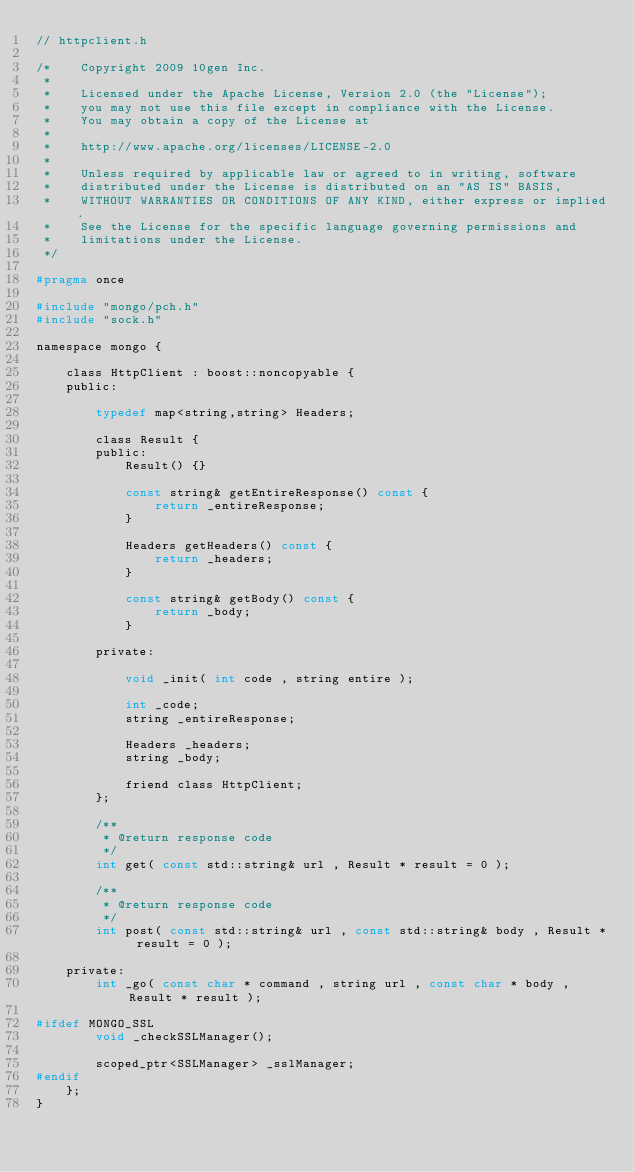Convert code to text. <code><loc_0><loc_0><loc_500><loc_500><_C_>// httpclient.h

/*    Copyright 2009 10gen Inc.
 *
 *    Licensed under the Apache License, Version 2.0 (the "License");
 *    you may not use this file except in compliance with the License.
 *    You may obtain a copy of the License at
 *
 *    http://www.apache.org/licenses/LICENSE-2.0
 *
 *    Unless required by applicable law or agreed to in writing, software
 *    distributed under the License is distributed on an "AS IS" BASIS,
 *    WITHOUT WARRANTIES OR CONDITIONS OF ANY KIND, either express or implied.
 *    See the License for the specific language governing permissions and
 *    limitations under the License.
 */

#pragma once

#include "mongo/pch.h"
#include "sock.h"

namespace mongo {

    class HttpClient : boost::noncopyable {
    public:

        typedef map<string,string> Headers;

        class Result {
        public:
            Result() {}

            const string& getEntireResponse() const {
                return _entireResponse;
            }

            Headers getHeaders() const {
                return _headers;
            }

            const string& getBody() const {
                return _body;
            }

        private:

            void _init( int code , string entire );

            int _code;
            string _entireResponse;

            Headers _headers;
            string _body;

            friend class HttpClient;
        };

        /**
         * @return response code
         */
        int get( const std::string& url , Result * result = 0 );

        /**
         * @return response code
         */
        int post( const std::string& url , const std::string& body , Result * result = 0 );

    private:
        int _go( const char * command , string url , const char * body , Result * result );

#ifdef MONGO_SSL
        void _checkSSLManager();

        scoped_ptr<SSLManager> _sslManager;
#endif
    };
}
</code> 